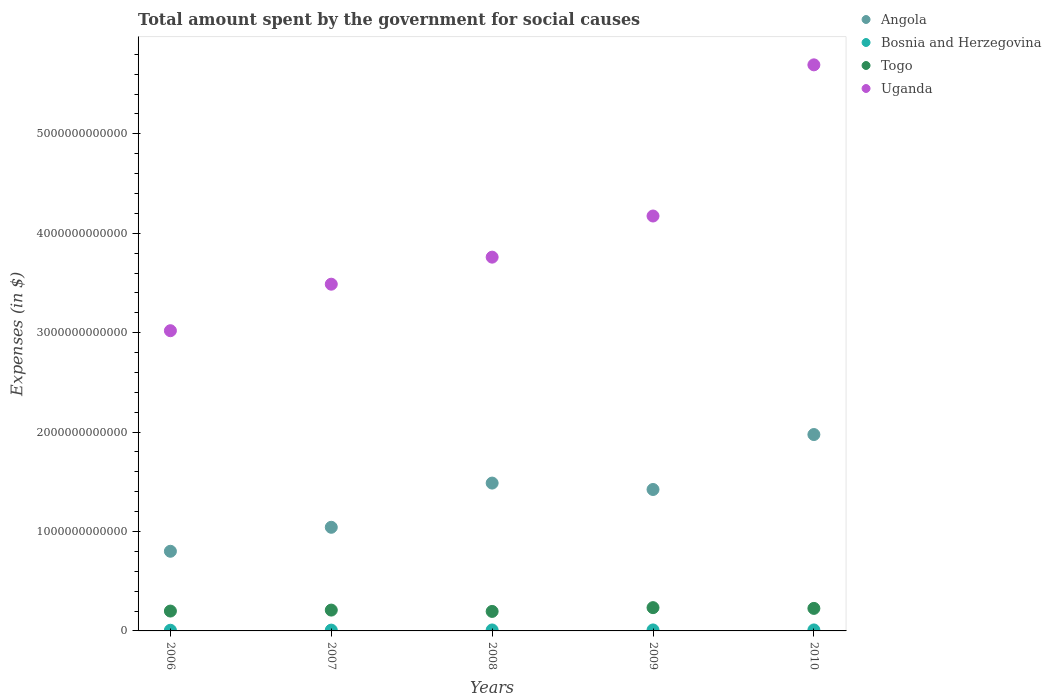How many different coloured dotlines are there?
Provide a short and direct response. 4. What is the amount spent for social causes by the government in Togo in 2009?
Provide a short and direct response. 2.34e+11. Across all years, what is the maximum amount spent for social causes by the government in Bosnia and Herzegovina?
Offer a terse response. 9.93e+09. Across all years, what is the minimum amount spent for social causes by the government in Uganda?
Provide a short and direct response. 3.02e+12. In which year was the amount spent for social causes by the government in Togo maximum?
Ensure brevity in your answer.  2009. What is the total amount spent for social causes by the government in Bosnia and Herzegovina in the graph?
Provide a succinct answer. 4.44e+1. What is the difference between the amount spent for social causes by the government in Togo in 2007 and that in 2008?
Provide a succinct answer. 1.34e+1. What is the difference between the amount spent for social causes by the government in Uganda in 2010 and the amount spent for social causes by the government in Angola in 2009?
Your answer should be very brief. 4.27e+12. What is the average amount spent for social causes by the government in Togo per year?
Your answer should be compact. 2.13e+11. In the year 2009, what is the difference between the amount spent for social causes by the government in Uganda and amount spent for social causes by the government in Angola?
Give a very brief answer. 2.75e+12. In how many years, is the amount spent for social causes by the government in Uganda greater than 5600000000000 $?
Your answer should be compact. 1. What is the ratio of the amount spent for social causes by the government in Bosnia and Herzegovina in 2006 to that in 2010?
Provide a succinct answer. 0.69. Is the amount spent for social causes by the government in Uganda in 2007 less than that in 2009?
Offer a very short reply. Yes. What is the difference between the highest and the second highest amount spent for social causes by the government in Angola?
Make the answer very short. 4.88e+11. What is the difference between the highest and the lowest amount spent for social causes by the government in Togo?
Your response must be concise. 3.80e+1. Is it the case that in every year, the sum of the amount spent for social causes by the government in Uganda and amount spent for social causes by the government in Angola  is greater than the sum of amount spent for social causes by the government in Bosnia and Herzegovina and amount spent for social causes by the government in Togo?
Your response must be concise. Yes. Does the amount spent for social causes by the government in Bosnia and Herzegovina monotonically increase over the years?
Offer a very short reply. Yes. Is the amount spent for social causes by the government in Angola strictly greater than the amount spent for social causes by the government in Bosnia and Herzegovina over the years?
Ensure brevity in your answer.  Yes. Is the amount spent for social causes by the government in Angola strictly less than the amount spent for social causes by the government in Uganda over the years?
Keep it short and to the point. Yes. How many years are there in the graph?
Provide a succinct answer. 5. What is the difference between two consecutive major ticks on the Y-axis?
Provide a short and direct response. 1.00e+12. Are the values on the major ticks of Y-axis written in scientific E-notation?
Offer a very short reply. No. Does the graph contain grids?
Your answer should be very brief. No. Where does the legend appear in the graph?
Provide a succinct answer. Top right. What is the title of the graph?
Ensure brevity in your answer.  Total amount spent by the government for social causes. Does "Kiribati" appear as one of the legend labels in the graph?
Your response must be concise. No. What is the label or title of the X-axis?
Offer a very short reply. Years. What is the label or title of the Y-axis?
Offer a very short reply. Expenses (in $). What is the Expenses (in $) in Angola in 2006?
Your answer should be compact. 8.01e+11. What is the Expenses (in $) of Bosnia and Herzegovina in 2006?
Offer a terse response. 6.82e+09. What is the Expenses (in $) in Togo in 2006?
Your answer should be very brief. 2.00e+11. What is the Expenses (in $) of Uganda in 2006?
Your answer should be compact. 3.02e+12. What is the Expenses (in $) of Angola in 2007?
Offer a terse response. 1.04e+12. What is the Expenses (in $) in Bosnia and Herzegovina in 2007?
Your answer should be very brief. 8.13e+09. What is the Expenses (in $) in Togo in 2007?
Offer a terse response. 2.10e+11. What is the Expenses (in $) in Uganda in 2007?
Make the answer very short. 3.49e+12. What is the Expenses (in $) of Angola in 2008?
Keep it short and to the point. 1.49e+12. What is the Expenses (in $) of Bosnia and Herzegovina in 2008?
Make the answer very short. 9.65e+09. What is the Expenses (in $) in Togo in 2008?
Ensure brevity in your answer.  1.96e+11. What is the Expenses (in $) of Uganda in 2008?
Offer a terse response. 3.76e+12. What is the Expenses (in $) of Angola in 2009?
Keep it short and to the point. 1.42e+12. What is the Expenses (in $) of Bosnia and Herzegovina in 2009?
Offer a terse response. 9.88e+09. What is the Expenses (in $) of Togo in 2009?
Make the answer very short. 2.34e+11. What is the Expenses (in $) of Uganda in 2009?
Make the answer very short. 4.17e+12. What is the Expenses (in $) in Angola in 2010?
Ensure brevity in your answer.  1.98e+12. What is the Expenses (in $) in Bosnia and Herzegovina in 2010?
Your answer should be compact. 9.93e+09. What is the Expenses (in $) of Togo in 2010?
Provide a succinct answer. 2.27e+11. What is the Expenses (in $) of Uganda in 2010?
Keep it short and to the point. 5.69e+12. Across all years, what is the maximum Expenses (in $) in Angola?
Offer a terse response. 1.98e+12. Across all years, what is the maximum Expenses (in $) in Bosnia and Herzegovina?
Provide a succinct answer. 9.93e+09. Across all years, what is the maximum Expenses (in $) in Togo?
Ensure brevity in your answer.  2.34e+11. Across all years, what is the maximum Expenses (in $) of Uganda?
Your answer should be compact. 5.69e+12. Across all years, what is the minimum Expenses (in $) in Angola?
Provide a succinct answer. 8.01e+11. Across all years, what is the minimum Expenses (in $) in Bosnia and Herzegovina?
Provide a short and direct response. 6.82e+09. Across all years, what is the minimum Expenses (in $) in Togo?
Offer a terse response. 1.96e+11. Across all years, what is the minimum Expenses (in $) in Uganda?
Your response must be concise. 3.02e+12. What is the total Expenses (in $) of Angola in the graph?
Your answer should be very brief. 6.73e+12. What is the total Expenses (in $) of Bosnia and Herzegovina in the graph?
Offer a terse response. 4.44e+1. What is the total Expenses (in $) in Togo in the graph?
Your response must be concise. 1.07e+12. What is the total Expenses (in $) in Uganda in the graph?
Make the answer very short. 2.01e+13. What is the difference between the Expenses (in $) in Angola in 2006 and that in 2007?
Make the answer very short. -2.41e+11. What is the difference between the Expenses (in $) of Bosnia and Herzegovina in 2006 and that in 2007?
Keep it short and to the point. -1.32e+09. What is the difference between the Expenses (in $) of Togo in 2006 and that in 2007?
Ensure brevity in your answer.  -9.82e+09. What is the difference between the Expenses (in $) in Uganda in 2006 and that in 2007?
Your answer should be compact. -4.68e+11. What is the difference between the Expenses (in $) in Angola in 2006 and that in 2008?
Offer a very short reply. -6.86e+11. What is the difference between the Expenses (in $) in Bosnia and Herzegovina in 2006 and that in 2008?
Keep it short and to the point. -2.84e+09. What is the difference between the Expenses (in $) in Togo in 2006 and that in 2008?
Offer a very short reply. 3.59e+09. What is the difference between the Expenses (in $) in Uganda in 2006 and that in 2008?
Offer a very short reply. -7.40e+11. What is the difference between the Expenses (in $) in Angola in 2006 and that in 2009?
Provide a succinct answer. -6.21e+11. What is the difference between the Expenses (in $) in Bosnia and Herzegovina in 2006 and that in 2009?
Your response must be concise. -3.06e+09. What is the difference between the Expenses (in $) in Togo in 2006 and that in 2009?
Your response must be concise. -3.44e+1. What is the difference between the Expenses (in $) of Uganda in 2006 and that in 2009?
Offer a terse response. -1.15e+12. What is the difference between the Expenses (in $) of Angola in 2006 and that in 2010?
Your response must be concise. -1.17e+12. What is the difference between the Expenses (in $) in Bosnia and Herzegovina in 2006 and that in 2010?
Offer a very short reply. -3.12e+09. What is the difference between the Expenses (in $) in Togo in 2006 and that in 2010?
Make the answer very short. -2.69e+1. What is the difference between the Expenses (in $) in Uganda in 2006 and that in 2010?
Your response must be concise. -2.67e+12. What is the difference between the Expenses (in $) in Angola in 2007 and that in 2008?
Your answer should be very brief. -4.45e+11. What is the difference between the Expenses (in $) in Bosnia and Herzegovina in 2007 and that in 2008?
Your answer should be compact. -1.52e+09. What is the difference between the Expenses (in $) in Togo in 2007 and that in 2008?
Offer a very short reply. 1.34e+1. What is the difference between the Expenses (in $) of Uganda in 2007 and that in 2008?
Offer a terse response. -2.72e+11. What is the difference between the Expenses (in $) of Angola in 2007 and that in 2009?
Make the answer very short. -3.80e+11. What is the difference between the Expenses (in $) of Bosnia and Herzegovina in 2007 and that in 2009?
Your answer should be very brief. -1.74e+09. What is the difference between the Expenses (in $) in Togo in 2007 and that in 2009?
Give a very brief answer. -2.46e+1. What is the difference between the Expenses (in $) in Uganda in 2007 and that in 2009?
Provide a succinct answer. -6.86e+11. What is the difference between the Expenses (in $) in Angola in 2007 and that in 2010?
Offer a terse response. -9.33e+11. What is the difference between the Expenses (in $) of Bosnia and Herzegovina in 2007 and that in 2010?
Offer a terse response. -1.80e+09. What is the difference between the Expenses (in $) in Togo in 2007 and that in 2010?
Your answer should be compact. -1.70e+1. What is the difference between the Expenses (in $) in Uganda in 2007 and that in 2010?
Your answer should be very brief. -2.21e+12. What is the difference between the Expenses (in $) of Angola in 2008 and that in 2009?
Provide a succinct answer. 6.45e+1. What is the difference between the Expenses (in $) in Bosnia and Herzegovina in 2008 and that in 2009?
Offer a very short reply. -2.22e+08. What is the difference between the Expenses (in $) in Togo in 2008 and that in 2009?
Offer a very short reply. -3.80e+1. What is the difference between the Expenses (in $) of Uganda in 2008 and that in 2009?
Give a very brief answer. -4.14e+11. What is the difference between the Expenses (in $) in Angola in 2008 and that in 2010?
Provide a succinct answer. -4.88e+11. What is the difference between the Expenses (in $) in Bosnia and Herzegovina in 2008 and that in 2010?
Make the answer very short. -2.80e+08. What is the difference between the Expenses (in $) in Togo in 2008 and that in 2010?
Provide a short and direct response. -3.05e+1. What is the difference between the Expenses (in $) of Uganda in 2008 and that in 2010?
Provide a succinct answer. -1.93e+12. What is the difference between the Expenses (in $) in Angola in 2009 and that in 2010?
Offer a very short reply. -5.53e+11. What is the difference between the Expenses (in $) of Bosnia and Herzegovina in 2009 and that in 2010?
Provide a succinct answer. -5.79e+07. What is the difference between the Expenses (in $) of Togo in 2009 and that in 2010?
Offer a very short reply. 7.54e+09. What is the difference between the Expenses (in $) in Uganda in 2009 and that in 2010?
Make the answer very short. -1.52e+12. What is the difference between the Expenses (in $) in Angola in 2006 and the Expenses (in $) in Bosnia and Herzegovina in 2007?
Your answer should be very brief. 7.93e+11. What is the difference between the Expenses (in $) in Angola in 2006 and the Expenses (in $) in Togo in 2007?
Your answer should be compact. 5.92e+11. What is the difference between the Expenses (in $) in Angola in 2006 and the Expenses (in $) in Uganda in 2007?
Your answer should be very brief. -2.69e+12. What is the difference between the Expenses (in $) of Bosnia and Herzegovina in 2006 and the Expenses (in $) of Togo in 2007?
Ensure brevity in your answer.  -2.03e+11. What is the difference between the Expenses (in $) in Bosnia and Herzegovina in 2006 and the Expenses (in $) in Uganda in 2007?
Your answer should be compact. -3.48e+12. What is the difference between the Expenses (in $) in Togo in 2006 and the Expenses (in $) in Uganda in 2007?
Offer a terse response. -3.29e+12. What is the difference between the Expenses (in $) of Angola in 2006 and the Expenses (in $) of Bosnia and Herzegovina in 2008?
Provide a succinct answer. 7.92e+11. What is the difference between the Expenses (in $) of Angola in 2006 and the Expenses (in $) of Togo in 2008?
Keep it short and to the point. 6.05e+11. What is the difference between the Expenses (in $) of Angola in 2006 and the Expenses (in $) of Uganda in 2008?
Your answer should be very brief. -2.96e+12. What is the difference between the Expenses (in $) of Bosnia and Herzegovina in 2006 and the Expenses (in $) of Togo in 2008?
Your answer should be compact. -1.89e+11. What is the difference between the Expenses (in $) of Bosnia and Herzegovina in 2006 and the Expenses (in $) of Uganda in 2008?
Make the answer very short. -3.75e+12. What is the difference between the Expenses (in $) of Togo in 2006 and the Expenses (in $) of Uganda in 2008?
Your response must be concise. -3.56e+12. What is the difference between the Expenses (in $) of Angola in 2006 and the Expenses (in $) of Bosnia and Herzegovina in 2009?
Keep it short and to the point. 7.91e+11. What is the difference between the Expenses (in $) of Angola in 2006 and the Expenses (in $) of Togo in 2009?
Provide a succinct answer. 5.67e+11. What is the difference between the Expenses (in $) in Angola in 2006 and the Expenses (in $) in Uganda in 2009?
Make the answer very short. -3.37e+12. What is the difference between the Expenses (in $) of Bosnia and Herzegovina in 2006 and the Expenses (in $) of Togo in 2009?
Provide a succinct answer. -2.27e+11. What is the difference between the Expenses (in $) of Bosnia and Herzegovina in 2006 and the Expenses (in $) of Uganda in 2009?
Provide a short and direct response. -4.17e+12. What is the difference between the Expenses (in $) of Togo in 2006 and the Expenses (in $) of Uganda in 2009?
Your answer should be compact. -3.97e+12. What is the difference between the Expenses (in $) of Angola in 2006 and the Expenses (in $) of Bosnia and Herzegovina in 2010?
Ensure brevity in your answer.  7.91e+11. What is the difference between the Expenses (in $) in Angola in 2006 and the Expenses (in $) in Togo in 2010?
Provide a short and direct response. 5.75e+11. What is the difference between the Expenses (in $) in Angola in 2006 and the Expenses (in $) in Uganda in 2010?
Offer a terse response. -4.89e+12. What is the difference between the Expenses (in $) in Bosnia and Herzegovina in 2006 and the Expenses (in $) in Togo in 2010?
Offer a very short reply. -2.20e+11. What is the difference between the Expenses (in $) of Bosnia and Herzegovina in 2006 and the Expenses (in $) of Uganda in 2010?
Keep it short and to the point. -5.69e+12. What is the difference between the Expenses (in $) of Togo in 2006 and the Expenses (in $) of Uganda in 2010?
Give a very brief answer. -5.49e+12. What is the difference between the Expenses (in $) of Angola in 2007 and the Expenses (in $) of Bosnia and Herzegovina in 2008?
Make the answer very short. 1.03e+12. What is the difference between the Expenses (in $) of Angola in 2007 and the Expenses (in $) of Togo in 2008?
Your answer should be very brief. 8.46e+11. What is the difference between the Expenses (in $) of Angola in 2007 and the Expenses (in $) of Uganda in 2008?
Your answer should be very brief. -2.72e+12. What is the difference between the Expenses (in $) in Bosnia and Herzegovina in 2007 and the Expenses (in $) in Togo in 2008?
Provide a short and direct response. -1.88e+11. What is the difference between the Expenses (in $) in Bosnia and Herzegovina in 2007 and the Expenses (in $) in Uganda in 2008?
Keep it short and to the point. -3.75e+12. What is the difference between the Expenses (in $) in Togo in 2007 and the Expenses (in $) in Uganda in 2008?
Make the answer very short. -3.55e+12. What is the difference between the Expenses (in $) of Angola in 2007 and the Expenses (in $) of Bosnia and Herzegovina in 2009?
Ensure brevity in your answer.  1.03e+12. What is the difference between the Expenses (in $) of Angola in 2007 and the Expenses (in $) of Togo in 2009?
Provide a short and direct response. 8.08e+11. What is the difference between the Expenses (in $) of Angola in 2007 and the Expenses (in $) of Uganda in 2009?
Your response must be concise. -3.13e+12. What is the difference between the Expenses (in $) of Bosnia and Herzegovina in 2007 and the Expenses (in $) of Togo in 2009?
Provide a succinct answer. -2.26e+11. What is the difference between the Expenses (in $) of Bosnia and Herzegovina in 2007 and the Expenses (in $) of Uganda in 2009?
Give a very brief answer. -4.17e+12. What is the difference between the Expenses (in $) in Togo in 2007 and the Expenses (in $) in Uganda in 2009?
Offer a terse response. -3.96e+12. What is the difference between the Expenses (in $) of Angola in 2007 and the Expenses (in $) of Bosnia and Herzegovina in 2010?
Your answer should be compact. 1.03e+12. What is the difference between the Expenses (in $) of Angola in 2007 and the Expenses (in $) of Togo in 2010?
Your response must be concise. 8.16e+11. What is the difference between the Expenses (in $) of Angola in 2007 and the Expenses (in $) of Uganda in 2010?
Make the answer very short. -4.65e+12. What is the difference between the Expenses (in $) in Bosnia and Herzegovina in 2007 and the Expenses (in $) in Togo in 2010?
Your response must be concise. -2.18e+11. What is the difference between the Expenses (in $) of Bosnia and Herzegovina in 2007 and the Expenses (in $) of Uganda in 2010?
Make the answer very short. -5.69e+12. What is the difference between the Expenses (in $) of Togo in 2007 and the Expenses (in $) of Uganda in 2010?
Give a very brief answer. -5.48e+12. What is the difference between the Expenses (in $) in Angola in 2008 and the Expenses (in $) in Bosnia and Herzegovina in 2009?
Provide a succinct answer. 1.48e+12. What is the difference between the Expenses (in $) in Angola in 2008 and the Expenses (in $) in Togo in 2009?
Make the answer very short. 1.25e+12. What is the difference between the Expenses (in $) in Angola in 2008 and the Expenses (in $) in Uganda in 2009?
Offer a very short reply. -2.69e+12. What is the difference between the Expenses (in $) in Bosnia and Herzegovina in 2008 and the Expenses (in $) in Togo in 2009?
Offer a very short reply. -2.24e+11. What is the difference between the Expenses (in $) of Bosnia and Herzegovina in 2008 and the Expenses (in $) of Uganda in 2009?
Your answer should be very brief. -4.16e+12. What is the difference between the Expenses (in $) of Togo in 2008 and the Expenses (in $) of Uganda in 2009?
Offer a very short reply. -3.98e+12. What is the difference between the Expenses (in $) in Angola in 2008 and the Expenses (in $) in Bosnia and Herzegovina in 2010?
Your answer should be very brief. 1.48e+12. What is the difference between the Expenses (in $) in Angola in 2008 and the Expenses (in $) in Togo in 2010?
Provide a short and direct response. 1.26e+12. What is the difference between the Expenses (in $) in Angola in 2008 and the Expenses (in $) in Uganda in 2010?
Your response must be concise. -4.21e+12. What is the difference between the Expenses (in $) in Bosnia and Herzegovina in 2008 and the Expenses (in $) in Togo in 2010?
Provide a succinct answer. -2.17e+11. What is the difference between the Expenses (in $) in Bosnia and Herzegovina in 2008 and the Expenses (in $) in Uganda in 2010?
Offer a very short reply. -5.68e+12. What is the difference between the Expenses (in $) of Togo in 2008 and the Expenses (in $) of Uganda in 2010?
Your answer should be compact. -5.50e+12. What is the difference between the Expenses (in $) in Angola in 2009 and the Expenses (in $) in Bosnia and Herzegovina in 2010?
Your response must be concise. 1.41e+12. What is the difference between the Expenses (in $) of Angola in 2009 and the Expenses (in $) of Togo in 2010?
Provide a short and direct response. 1.20e+12. What is the difference between the Expenses (in $) of Angola in 2009 and the Expenses (in $) of Uganda in 2010?
Offer a very short reply. -4.27e+12. What is the difference between the Expenses (in $) in Bosnia and Herzegovina in 2009 and the Expenses (in $) in Togo in 2010?
Ensure brevity in your answer.  -2.17e+11. What is the difference between the Expenses (in $) of Bosnia and Herzegovina in 2009 and the Expenses (in $) of Uganda in 2010?
Provide a succinct answer. -5.68e+12. What is the difference between the Expenses (in $) of Togo in 2009 and the Expenses (in $) of Uganda in 2010?
Give a very brief answer. -5.46e+12. What is the average Expenses (in $) in Angola per year?
Your response must be concise. 1.35e+12. What is the average Expenses (in $) in Bosnia and Herzegovina per year?
Keep it short and to the point. 8.88e+09. What is the average Expenses (in $) of Togo per year?
Your response must be concise. 2.13e+11. What is the average Expenses (in $) in Uganda per year?
Offer a terse response. 4.03e+12. In the year 2006, what is the difference between the Expenses (in $) in Angola and Expenses (in $) in Bosnia and Herzegovina?
Give a very brief answer. 7.94e+11. In the year 2006, what is the difference between the Expenses (in $) in Angola and Expenses (in $) in Togo?
Your answer should be very brief. 6.02e+11. In the year 2006, what is the difference between the Expenses (in $) of Angola and Expenses (in $) of Uganda?
Your answer should be very brief. -2.22e+12. In the year 2006, what is the difference between the Expenses (in $) in Bosnia and Herzegovina and Expenses (in $) in Togo?
Your answer should be compact. -1.93e+11. In the year 2006, what is the difference between the Expenses (in $) in Bosnia and Herzegovina and Expenses (in $) in Uganda?
Your response must be concise. -3.01e+12. In the year 2006, what is the difference between the Expenses (in $) in Togo and Expenses (in $) in Uganda?
Offer a very short reply. -2.82e+12. In the year 2007, what is the difference between the Expenses (in $) of Angola and Expenses (in $) of Bosnia and Herzegovina?
Your answer should be very brief. 1.03e+12. In the year 2007, what is the difference between the Expenses (in $) in Angola and Expenses (in $) in Togo?
Ensure brevity in your answer.  8.33e+11. In the year 2007, what is the difference between the Expenses (in $) in Angola and Expenses (in $) in Uganda?
Give a very brief answer. -2.45e+12. In the year 2007, what is the difference between the Expenses (in $) of Bosnia and Herzegovina and Expenses (in $) of Togo?
Your answer should be very brief. -2.01e+11. In the year 2007, what is the difference between the Expenses (in $) of Bosnia and Herzegovina and Expenses (in $) of Uganda?
Ensure brevity in your answer.  -3.48e+12. In the year 2007, what is the difference between the Expenses (in $) in Togo and Expenses (in $) in Uganda?
Provide a short and direct response. -3.28e+12. In the year 2008, what is the difference between the Expenses (in $) in Angola and Expenses (in $) in Bosnia and Herzegovina?
Offer a terse response. 1.48e+12. In the year 2008, what is the difference between the Expenses (in $) in Angola and Expenses (in $) in Togo?
Your answer should be very brief. 1.29e+12. In the year 2008, what is the difference between the Expenses (in $) of Angola and Expenses (in $) of Uganda?
Provide a short and direct response. -2.27e+12. In the year 2008, what is the difference between the Expenses (in $) of Bosnia and Herzegovina and Expenses (in $) of Togo?
Your response must be concise. -1.86e+11. In the year 2008, what is the difference between the Expenses (in $) of Bosnia and Herzegovina and Expenses (in $) of Uganda?
Your answer should be very brief. -3.75e+12. In the year 2008, what is the difference between the Expenses (in $) in Togo and Expenses (in $) in Uganda?
Offer a terse response. -3.56e+12. In the year 2009, what is the difference between the Expenses (in $) of Angola and Expenses (in $) of Bosnia and Herzegovina?
Ensure brevity in your answer.  1.41e+12. In the year 2009, what is the difference between the Expenses (in $) of Angola and Expenses (in $) of Togo?
Offer a terse response. 1.19e+12. In the year 2009, what is the difference between the Expenses (in $) of Angola and Expenses (in $) of Uganda?
Offer a terse response. -2.75e+12. In the year 2009, what is the difference between the Expenses (in $) in Bosnia and Herzegovina and Expenses (in $) in Togo?
Offer a terse response. -2.24e+11. In the year 2009, what is the difference between the Expenses (in $) in Bosnia and Herzegovina and Expenses (in $) in Uganda?
Ensure brevity in your answer.  -4.16e+12. In the year 2009, what is the difference between the Expenses (in $) in Togo and Expenses (in $) in Uganda?
Your answer should be very brief. -3.94e+12. In the year 2010, what is the difference between the Expenses (in $) in Angola and Expenses (in $) in Bosnia and Herzegovina?
Make the answer very short. 1.97e+12. In the year 2010, what is the difference between the Expenses (in $) in Angola and Expenses (in $) in Togo?
Give a very brief answer. 1.75e+12. In the year 2010, what is the difference between the Expenses (in $) of Angola and Expenses (in $) of Uganda?
Provide a succinct answer. -3.72e+12. In the year 2010, what is the difference between the Expenses (in $) of Bosnia and Herzegovina and Expenses (in $) of Togo?
Your answer should be very brief. -2.17e+11. In the year 2010, what is the difference between the Expenses (in $) in Bosnia and Herzegovina and Expenses (in $) in Uganda?
Your answer should be very brief. -5.68e+12. In the year 2010, what is the difference between the Expenses (in $) in Togo and Expenses (in $) in Uganda?
Provide a short and direct response. -5.47e+12. What is the ratio of the Expenses (in $) in Angola in 2006 to that in 2007?
Your response must be concise. 0.77. What is the ratio of the Expenses (in $) of Bosnia and Herzegovina in 2006 to that in 2007?
Offer a terse response. 0.84. What is the ratio of the Expenses (in $) of Togo in 2006 to that in 2007?
Your answer should be very brief. 0.95. What is the ratio of the Expenses (in $) in Uganda in 2006 to that in 2007?
Make the answer very short. 0.87. What is the ratio of the Expenses (in $) of Angola in 2006 to that in 2008?
Your answer should be very brief. 0.54. What is the ratio of the Expenses (in $) in Bosnia and Herzegovina in 2006 to that in 2008?
Provide a short and direct response. 0.71. What is the ratio of the Expenses (in $) of Togo in 2006 to that in 2008?
Make the answer very short. 1.02. What is the ratio of the Expenses (in $) of Uganda in 2006 to that in 2008?
Ensure brevity in your answer.  0.8. What is the ratio of the Expenses (in $) in Angola in 2006 to that in 2009?
Your answer should be very brief. 0.56. What is the ratio of the Expenses (in $) of Bosnia and Herzegovina in 2006 to that in 2009?
Ensure brevity in your answer.  0.69. What is the ratio of the Expenses (in $) of Togo in 2006 to that in 2009?
Provide a succinct answer. 0.85. What is the ratio of the Expenses (in $) in Uganda in 2006 to that in 2009?
Offer a very short reply. 0.72. What is the ratio of the Expenses (in $) in Angola in 2006 to that in 2010?
Offer a very short reply. 0.41. What is the ratio of the Expenses (in $) of Bosnia and Herzegovina in 2006 to that in 2010?
Your response must be concise. 0.69. What is the ratio of the Expenses (in $) of Togo in 2006 to that in 2010?
Keep it short and to the point. 0.88. What is the ratio of the Expenses (in $) in Uganda in 2006 to that in 2010?
Ensure brevity in your answer.  0.53. What is the ratio of the Expenses (in $) in Angola in 2007 to that in 2008?
Your response must be concise. 0.7. What is the ratio of the Expenses (in $) in Bosnia and Herzegovina in 2007 to that in 2008?
Provide a short and direct response. 0.84. What is the ratio of the Expenses (in $) in Togo in 2007 to that in 2008?
Make the answer very short. 1.07. What is the ratio of the Expenses (in $) of Uganda in 2007 to that in 2008?
Provide a short and direct response. 0.93. What is the ratio of the Expenses (in $) of Angola in 2007 to that in 2009?
Offer a very short reply. 0.73. What is the ratio of the Expenses (in $) in Bosnia and Herzegovina in 2007 to that in 2009?
Your answer should be very brief. 0.82. What is the ratio of the Expenses (in $) of Togo in 2007 to that in 2009?
Your answer should be very brief. 0.9. What is the ratio of the Expenses (in $) in Uganda in 2007 to that in 2009?
Your response must be concise. 0.84. What is the ratio of the Expenses (in $) of Angola in 2007 to that in 2010?
Your answer should be compact. 0.53. What is the ratio of the Expenses (in $) in Bosnia and Herzegovina in 2007 to that in 2010?
Provide a succinct answer. 0.82. What is the ratio of the Expenses (in $) in Togo in 2007 to that in 2010?
Keep it short and to the point. 0.92. What is the ratio of the Expenses (in $) in Uganda in 2007 to that in 2010?
Offer a terse response. 0.61. What is the ratio of the Expenses (in $) in Angola in 2008 to that in 2009?
Offer a terse response. 1.05. What is the ratio of the Expenses (in $) of Bosnia and Herzegovina in 2008 to that in 2009?
Your response must be concise. 0.98. What is the ratio of the Expenses (in $) of Togo in 2008 to that in 2009?
Offer a very short reply. 0.84. What is the ratio of the Expenses (in $) of Uganda in 2008 to that in 2009?
Provide a short and direct response. 0.9. What is the ratio of the Expenses (in $) in Angola in 2008 to that in 2010?
Offer a very short reply. 0.75. What is the ratio of the Expenses (in $) in Bosnia and Herzegovina in 2008 to that in 2010?
Provide a short and direct response. 0.97. What is the ratio of the Expenses (in $) in Togo in 2008 to that in 2010?
Make the answer very short. 0.87. What is the ratio of the Expenses (in $) of Uganda in 2008 to that in 2010?
Give a very brief answer. 0.66. What is the ratio of the Expenses (in $) in Angola in 2009 to that in 2010?
Make the answer very short. 0.72. What is the ratio of the Expenses (in $) in Bosnia and Herzegovina in 2009 to that in 2010?
Make the answer very short. 0.99. What is the ratio of the Expenses (in $) in Uganda in 2009 to that in 2010?
Keep it short and to the point. 0.73. What is the difference between the highest and the second highest Expenses (in $) of Angola?
Your answer should be compact. 4.88e+11. What is the difference between the highest and the second highest Expenses (in $) in Bosnia and Herzegovina?
Provide a short and direct response. 5.79e+07. What is the difference between the highest and the second highest Expenses (in $) of Togo?
Your response must be concise. 7.54e+09. What is the difference between the highest and the second highest Expenses (in $) of Uganda?
Keep it short and to the point. 1.52e+12. What is the difference between the highest and the lowest Expenses (in $) of Angola?
Keep it short and to the point. 1.17e+12. What is the difference between the highest and the lowest Expenses (in $) of Bosnia and Herzegovina?
Offer a very short reply. 3.12e+09. What is the difference between the highest and the lowest Expenses (in $) of Togo?
Keep it short and to the point. 3.80e+1. What is the difference between the highest and the lowest Expenses (in $) in Uganda?
Your response must be concise. 2.67e+12. 